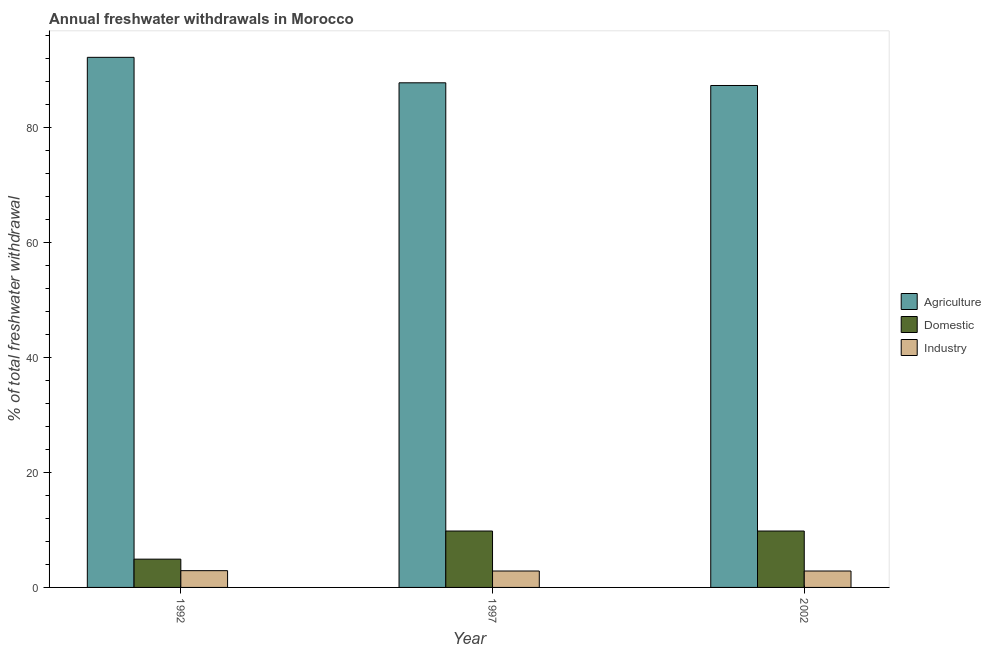How many different coloured bars are there?
Ensure brevity in your answer.  3. How many groups of bars are there?
Give a very brief answer. 3. How many bars are there on the 2nd tick from the right?
Your answer should be compact. 3. In how many cases, is the number of bars for a given year not equal to the number of legend labels?
Make the answer very short. 0. What is the percentage of freshwater withdrawal for agriculture in 1997?
Ensure brevity in your answer.  87.78. Across all years, what is the maximum percentage of freshwater withdrawal for domestic purposes?
Give a very brief answer. 9.81. Across all years, what is the minimum percentage of freshwater withdrawal for domestic purposes?
Keep it short and to the point. 4.92. In which year was the percentage of freshwater withdrawal for domestic purposes minimum?
Give a very brief answer. 1992. What is the total percentage of freshwater withdrawal for agriculture in the graph?
Provide a short and direct response. 267.3. What is the difference between the percentage of freshwater withdrawal for domestic purposes in 1992 and that in 1997?
Make the answer very short. -4.89. What is the difference between the percentage of freshwater withdrawal for industry in 1992 and the percentage of freshwater withdrawal for agriculture in 2002?
Offer a very short reply. 0.06. What is the average percentage of freshwater withdrawal for agriculture per year?
Offer a terse response. 89.1. In the year 1997, what is the difference between the percentage of freshwater withdrawal for domestic purposes and percentage of freshwater withdrawal for industry?
Give a very brief answer. 0. Is the percentage of freshwater withdrawal for domestic purposes in 1992 less than that in 1997?
Offer a terse response. Yes. What is the difference between the highest and the second highest percentage of freshwater withdrawal for industry?
Make the answer very short. 0.06. What is the difference between the highest and the lowest percentage of freshwater withdrawal for agriculture?
Your response must be concise. 4.9. In how many years, is the percentage of freshwater withdrawal for industry greater than the average percentage of freshwater withdrawal for industry taken over all years?
Keep it short and to the point. 1. Is the sum of the percentage of freshwater withdrawal for domestic purposes in 1992 and 2002 greater than the maximum percentage of freshwater withdrawal for industry across all years?
Provide a short and direct response. Yes. What does the 2nd bar from the left in 1992 represents?
Provide a succinct answer. Domestic. What does the 1st bar from the right in 1997 represents?
Provide a succinct answer. Industry. Is it the case that in every year, the sum of the percentage of freshwater withdrawal for agriculture and percentage of freshwater withdrawal for domestic purposes is greater than the percentage of freshwater withdrawal for industry?
Keep it short and to the point. Yes. Are all the bars in the graph horizontal?
Ensure brevity in your answer.  No. How many years are there in the graph?
Your answer should be very brief. 3. What is the difference between two consecutive major ticks on the Y-axis?
Provide a succinct answer. 20. Are the values on the major ticks of Y-axis written in scientific E-notation?
Provide a succinct answer. No. Where does the legend appear in the graph?
Offer a terse response. Center right. How are the legend labels stacked?
Keep it short and to the point. Vertical. What is the title of the graph?
Your response must be concise. Annual freshwater withdrawals in Morocco. What is the label or title of the Y-axis?
Provide a succinct answer. % of total freshwater withdrawal. What is the % of total freshwater withdrawal of Agriculture in 1992?
Provide a short and direct response. 92.21. What is the % of total freshwater withdrawal of Domestic in 1992?
Provide a succinct answer. 4.92. What is the % of total freshwater withdrawal of Industry in 1992?
Your answer should be compact. 2.92. What is the % of total freshwater withdrawal of Agriculture in 1997?
Keep it short and to the point. 87.78. What is the % of total freshwater withdrawal in Domestic in 1997?
Make the answer very short. 9.81. What is the % of total freshwater withdrawal of Industry in 1997?
Offer a terse response. 2.85. What is the % of total freshwater withdrawal in Agriculture in 2002?
Provide a short and direct response. 87.31. What is the % of total freshwater withdrawal of Domestic in 2002?
Your answer should be compact. 9.81. What is the % of total freshwater withdrawal in Industry in 2002?
Keep it short and to the point. 2.85. Across all years, what is the maximum % of total freshwater withdrawal of Agriculture?
Offer a very short reply. 92.21. Across all years, what is the maximum % of total freshwater withdrawal in Domestic?
Offer a very short reply. 9.81. Across all years, what is the maximum % of total freshwater withdrawal of Industry?
Your answer should be compact. 2.92. Across all years, what is the minimum % of total freshwater withdrawal in Agriculture?
Your response must be concise. 87.31. Across all years, what is the minimum % of total freshwater withdrawal in Domestic?
Give a very brief answer. 4.92. Across all years, what is the minimum % of total freshwater withdrawal of Industry?
Your answer should be very brief. 2.85. What is the total % of total freshwater withdrawal in Agriculture in the graph?
Keep it short and to the point. 267.3. What is the total % of total freshwater withdrawal in Domestic in the graph?
Your response must be concise. 24.54. What is the total % of total freshwater withdrawal in Industry in the graph?
Your response must be concise. 8.63. What is the difference between the % of total freshwater withdrawal in Agriculture in 1992 and that in 1997?
Make the answer very short. 4.43. What is the difference between the % of total freshwater withdrawal in Domestic in 1992 and that in 1997?
Make the answer very short. -4.89. What is the difference between the % of total freshwater withdrawal in Industry in 1992 and that in 1997?
Ensure brevity in your answer.  0.06. What is the difference between the % of total freshwater withdrawal of Agriculture in 1992 and that in 2002?
Offer a very short reply. 4.9. What is the difference between the % of total freshwater withdrawal in Domestic in 1992 and that in 2002?
Offer a very short reply. -4.89. What is the difference between the % of total freshwater withdrawal in Industry in 1992 and that in 2002?
Provide a short and direct response. 0.06. What is the difference between the % of total freshwater withdrawal in Agriculture in 1997 and that in 2002?
Give a very brief answer. 0.47. What is the difference between the % of total freshwater withdrawal of Industry in 1997 and that in 2002?
Keep it short and to the point. 0. What is the difference between the % of total freshwater withdrawal in Agriculture in 1992 and the % of total freshwater withdrawal in Domestic in 1997?
Provide a succinct answer. 82.4. What is the difference between the % of total freshwater withdrawal in Agriculture in 1992 and the % of total freshwater withdrawal in Industry in 1997?
Your answer should be very brief. 89.36. What is the difference between the % of total freshwater withdrawal in Domestic in 1992 and the % of total freshwater withdrawal in Industry in 1997?
Provide a succinct answer. 2.06. What is the difference between the % of total freshwater withdrawal in Agriculture in 1992 and the % of total freshwater withdrawal in Domestic in 2002?
Provide a short and direct response. 82.4. What is the difference between the % of total freshwater withdrawal of Agriculture in 1992 and the % of total freshwater withdrawal of Industry in 2002?
Provide a succinct answer. 89.36. What is the difference between the % of total freshwater withdrawal of Domestic in 1992 and the % of total freshwater withdrawal of Industry in 2002?
Provide a short and direct response. 2.06. What is the difference between the % of total freshwater withdrawal of Agriculture in 1997 and the % of total freshwater withdrawal of Domestic in 2002?
Your answer should be very brief. 77.97. What is the difference between the % of total freshwater withdrawal of Agriculture in 1997 and the % of total freshwater withdrawal of Industry in 2002?
Make the answer very short. 84.92. What is the difference between the % of total freshwater withdrawal of Domestic in 1997 and the % of total freshwater withdrawal of Industry in 2002?
Your answer should be compact. 6.96. What is the average % of total freshwater withdrawal in Agriculture per year?
Offer a terse response. 89.1. What is the average % of total freshwater withdrawal in Domestic per year?
Provide a short and direct response. 8.18. What is the average % of total freshwater withdrawal of Industry per year?
Make the answer very short. 2.88. In the year 1992, what is the difference between the % of total freshwater withdrawal in Agriculture and % of total freshwater withdrawal in Domestic?
Provide a short and direct response. 87.29. In the year 1992, what is the difference between the % of total freshwater withdrawal of Agriculture and % of total freshwater withdrawal of Industry?
Ensure brevity in your answer.  89.29. In the year 1992, what is the difference between the % of total freshwater withdrawal of Domestic and % of total freshwater withdrawal of Industry?
Keep it short and to the point. 2. In the year 1997, what is the difference between the % of total freshwater withdrawal in Agriculture and % of total freshwater withdrawal in Domestic?
Keep it short and to the point. 77.97. In the year 1997, what is the difference between the % of total freshwater withdrawal of Agriculture and % of total freshwater withdrawal of Industry?
Offer a very short reply. 84.92. In the year 1997, what is the difference between the % of total freshwater withdrawal of Domestic and % of total freshwater withdrawal of Industry?
Keep it short and to the point. 6.96. In the year 2002, what is the difference between the % of total freshwater withdrawal of Agriculture and % of total freshwater withdrawal of Domestic?
Your answer should be compact. 77.5. In the year 2002, what is the difference between the % of total freshwater withdrawal in Agriculture and % of total freshwater withdrawal in Industry?
Keep it short and to the point. 84.45. In the year 2002, what is the difference between the % of total freshwater withdrawal of Domestic and % of total freshwater withdrawal of Industry?
Offer a very short reply. 6.96. What is the ratio of the % of total freshwater withdrawal in Agriculture in 1992 to that in 1997?
Keep it short and to the point. 1.05. What is the ratio of the % of total freshwater withdrawal in Domestic in 1992 to that in 1997?
Offer a very short reply. 0.5. What is the ratio of the % of total freshwater withdrawal of Industry in 1992 to that in 1997?
Ensure brevity in your answer.  1.02. What is the ratio of the % of total freshwater withdrawal in Agriculture in 1992 to that in 2002?
Your answer should be compact. 1.06. What is the ratio of the % of total freshwater withdrawal of Domestic in 1992 to that in 2002?
Provide a short and direct response. 0.5. What is the ratio of the % of total freshwater withdrawal in Industry in 1992 to that in 2002?
Ensure brevity in your answer.  1.02. What is the ratio of the % of total freshwater withdrawal in Agriculture in 1997 to that in 2002?
Make the answer very short. 1.01. What is the ratio of the % of total freshwater withdrawal of Industry in 1997 to that in 2002?
Ensure brevity in your answer.  1. What is the difference between the highest and the second highest % of total freshwater withdrawal in Agriculture?
Your answer should be very brief. 4.43. What is the difference between the highest and the second highest % of total freshwater withdrawal in Domestic?
Offer a terse response. 0. What is the difference between the highest and the second highest % of total freshwater withdrawal of Industry?
Your response must be concise. 0.06. What is the difference between the highest and the lowest % of total freshwater withdrawal of Agriculture?
Offer a terse response. 4.9. What is the difference between the highest and the lowest % of total freshwater withdrawal of Domestic?
Make the answer very short. 4.89. What is the difference between the highest and the lowest % of total freshwater withdrawal in Industry?
Your response must be concise. 0.06. 